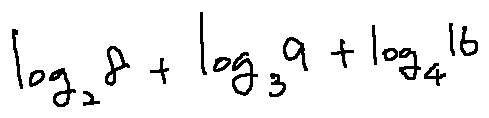Convert formula to latex. <formula><loc_0><loc_0><loc_500><loc_500>\log _ { 2 } 8 + \log _ { 3 } 9 + \log _ { 4 } 1 6</formula> 